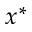Convert formula to latex. <formula><loc_0><loc_0><loc_500><loc_500>x ^ { * }</formula> 